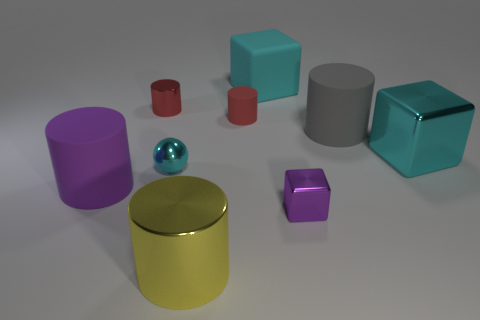Are there fewer big objects on the left side of the large matte cube than big metal blocks that are in front of the tiny cyan thing?
Provide a short and direct response. No. Does the tiny metallic block have the same color as the small ball?
Offer a very short reply. No. Is the number of big cyan objects that are on the left side of the gray object less than the number of metallic objects?
Your answer should be compact. Yes. There is a cylinder that is the same color as the tiny rubber thing; what material is it?
Keep it short and to the point. Metal. Do the small cyan ball and the purple block have the same material?
Offer a very short reply. Yes. What number of large yellow things are made of the same material as the small sphere?
Your answer should be very brief. 1. What color is the cube that is made of the same material as the large gray object?
Ensure brevity in your answer.  Cyan. What is the shape of the big cyan matte object?
Your response must be concise. Cube. What is the material of the small red cylinder on the right side of the tiny shiny sphere?
Provide a short and direct response. Rubber. Are there any small cylinders of the same color as the ball?
Your response must be concise. No. 